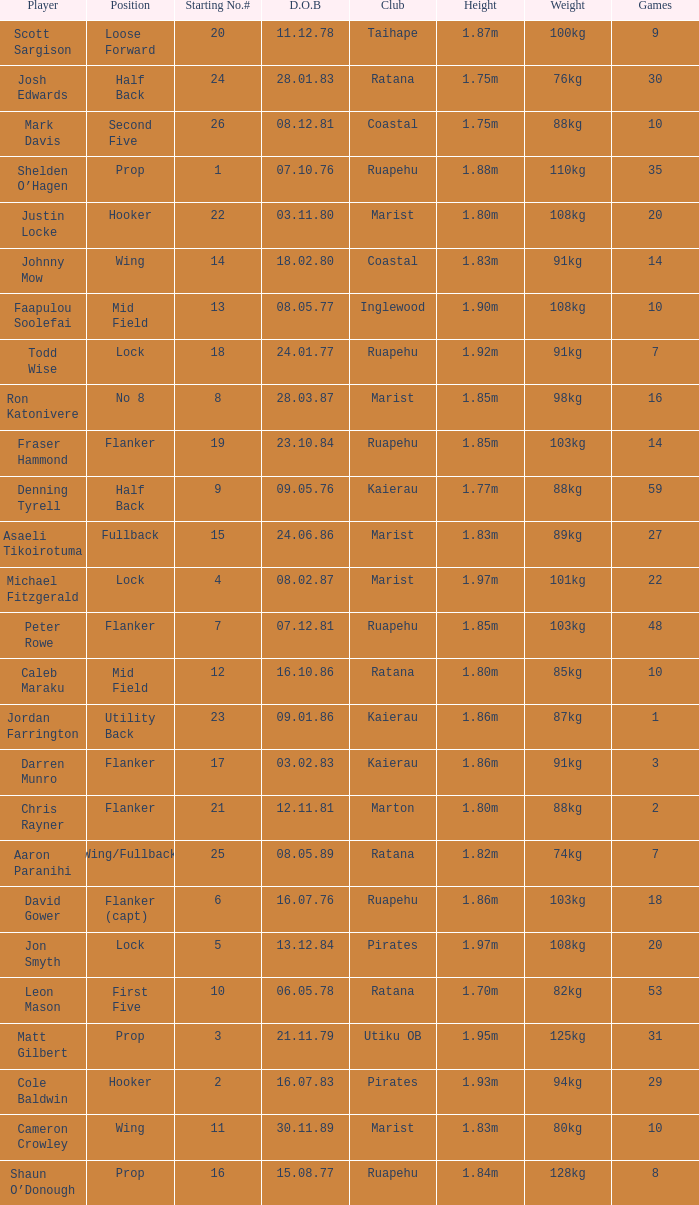What is the date of birth for the player in the Inglewood club? 80577.0. 